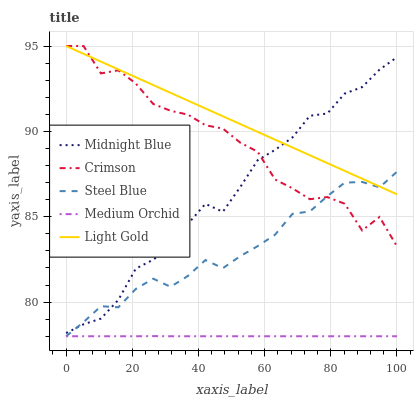Does Medium Orchid have the minimum area under the curve?
Answer yes or no. Yes. Does Light Gold have the maximum area under the curve?
Answer yes or no. Yes. Does Light Gold have the minimum area under the curve?
Answer yes or no. No. Does Medium Orchid have the maximum area under the curve?
Answer yes or no. No. Is Light Gold the smoothest?
Answer yes or no. Yes. Is Crimson the roughest?
Answer yes or no. Yes. Is Medium Orchid the smoothest?
Answer yes or no. No. Is Medium Orchid the roughest?
Answer yes or no. No. Does Light Gold have the lowest value?
Answer yes or no. No. Does Light Gold have the highest value?
Answer yes or no. Yes. Does Medium Orchid have the highest value?
Answer yes or no. No. Is Medium Orchid less than Light Gold?
Answer yes or no. Yes. Is Light Gold greater than Medium Orchid?
Answer yes or no. Yes. Does Crimson intersect Light Gold?
Answer yes or no. Yes. Is Crimson less than Light Gold?
Answer yes or no. No. Is Crimson greater than Light Gold?
Answer yes or no. No. Does Medium Orchid intersect Light Gold?
Answer yes or no. No. 